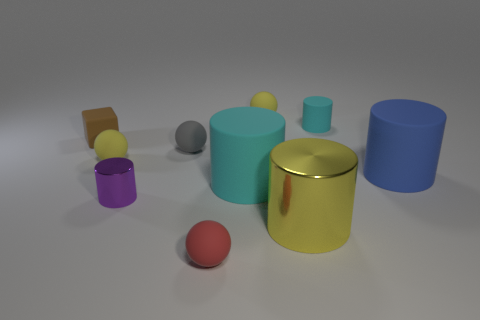How does the lighting in this image affect the appearance of the objects? The lighting in the image creates soft shadows and subtle highlights on the objects, suggesting a diffuse light source. This type of lighting reduces harsh shadows and allows for the textures and colors of the objects to be visible without strong contrasts, providing a calm and even presentation of the scene. 